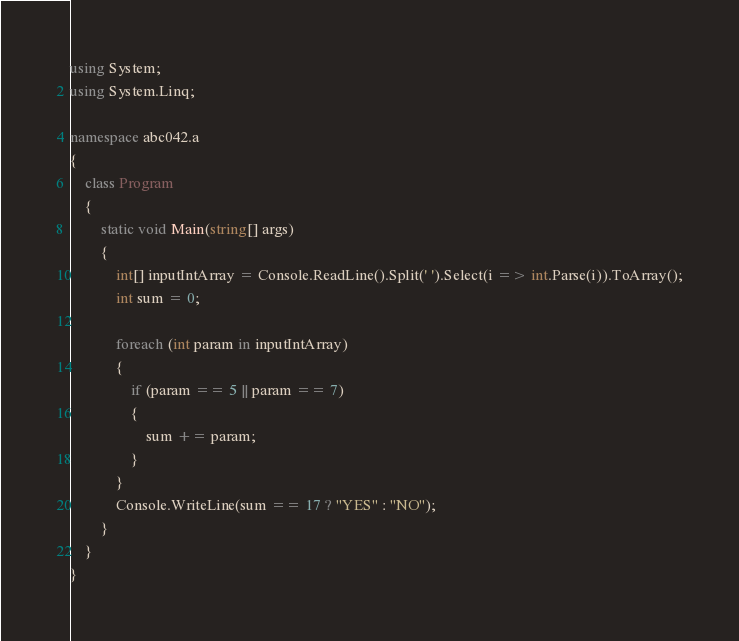Convert code to text. <code><loc_0><loc_0><loc_500><loc_500><_C#_>using System;
using System.Linq;

namespace abc042.a
{
    class Program
    {
        static void Main(string[] args)
        {
            int[] inputIntArray = Console.ReadLine().Split(' ').Select(i => int.Parse(i)).ToArray();
            int sum = 0;

            foreach (int param in inputIntArray)
            {
                if (param == 5 || param == 7)
                {
                    sum += param;
                }
            }
            Console.WriteLine(sum == 17 ? "YES" : "NO");
        }
    }
}
</code> 